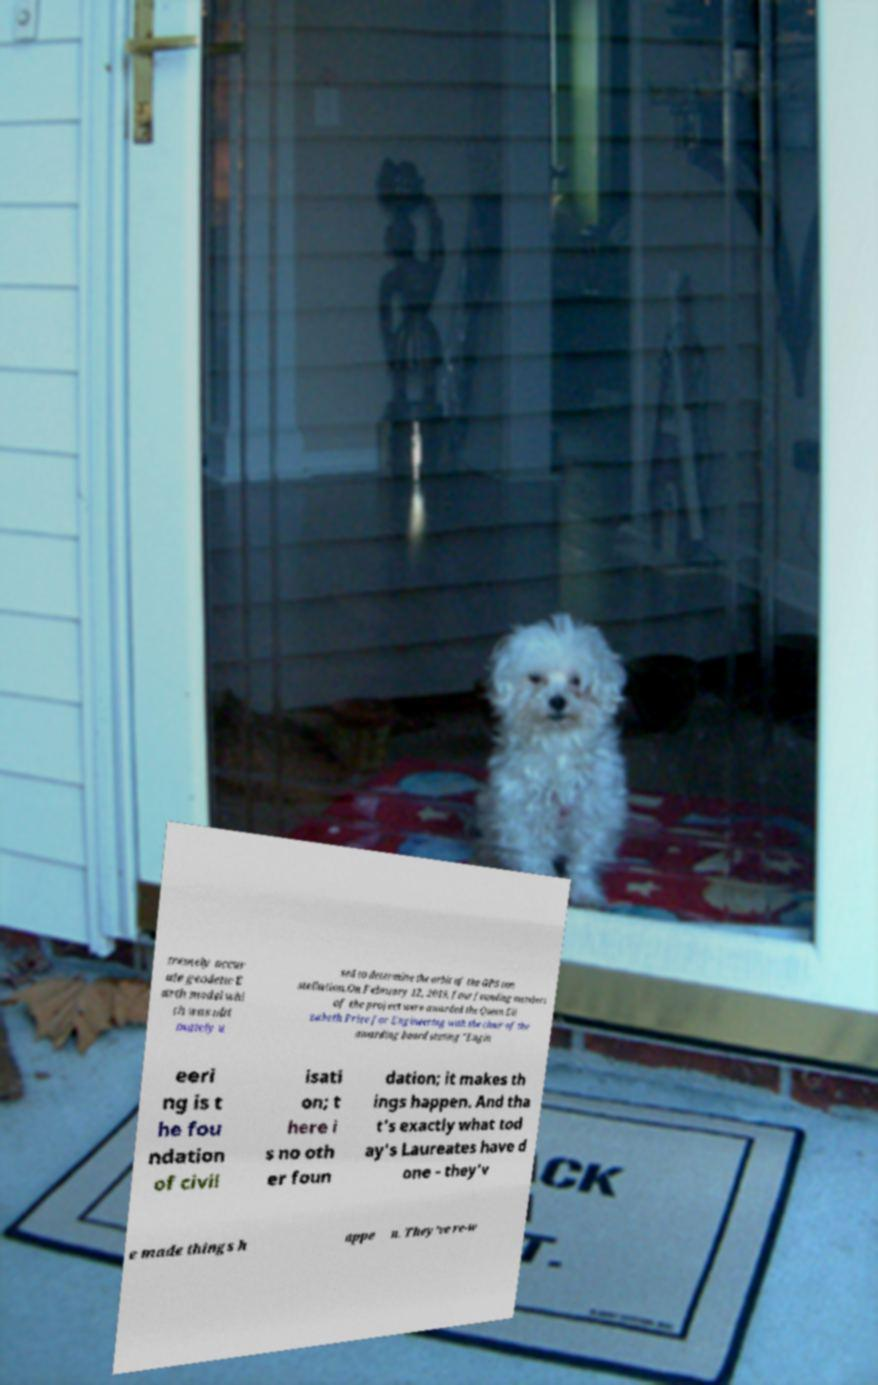Please identify and transcribe the text found in this image. tremely accur ate geodetic E arth model whi ch was ulti mately u sed to determine the orbit of the GPS con stellation.On February 12, 2019, four founding members of the project were awarded the Queen Eli zabeth Prize for Engineering with the chair of the awarding board stating "Engin eeri ng is t he fou ndation of civil isati on; t here i s no oth er foun dation; it makes th ings happen. And tha t's exactly what tod ay's Laureates have d one - they'v e made things h appe n. They've re-w 